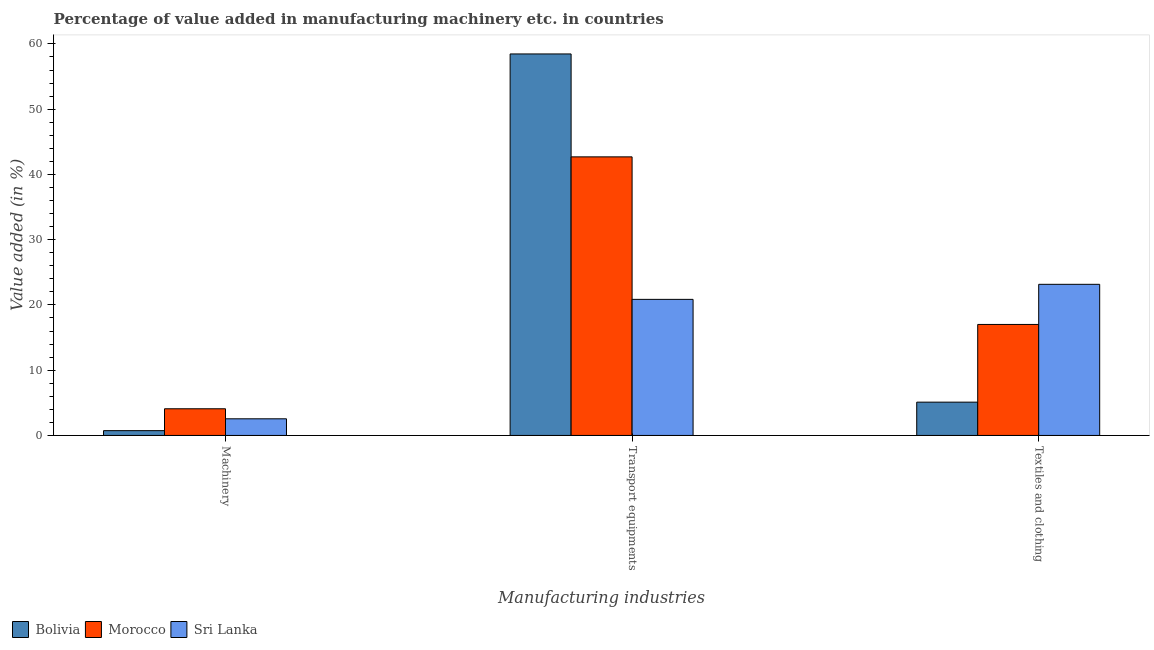How many different coloured bars are there?
Provide a short and direct response. 3. Are the number of bars per tick equal to the number of legend labels?
Your response must be concise. Yes. What is the label of the 2nd group of bars from the left?
Provide a short and direct response. Transport equipments. What is the value added in manufacturing machinery in Morocco?
Give a very brief answer. 4.09. Across all countries, what is the maximum value added in manufacturing transport equipments?
Provide a succinct answer. 58.46. Across all countries, what is the minimum value added in manufacturing transport equipments?
Your response must be concise. 20.85. In which country was the value added in manufacturing textile and clothing maximum?
Ensure brevity in your answer.  Sri Lanka. In which country was the value added in manufacturing textile and clothing minimum?
Your answer should be very brief. Bolivia. What is the total value added in manufacturing textile and clothing in the graph?
Offer a terse response. 45.27. What is the difference between the value added in manufacturing textile and clothing in Morocco and that in Sri Lanka?
Offer a very short reply. -6.15. What is the difference between the value added in manufacturing transport equipments in Bolivia and the value added in manufacturing textile and clothing in Morocco?
Ensure brevity in your answer.  41.45. What is the average value added in manufacturing textile and clothing per country?
Provide a short and direct response. 15.09. What is the difference between the value added in manufacturing machinery and value added in manufacturing textile and clothing in Bolivia?
Make the answer very short. -4.37. What is the ratio of the value added in manufacturing textile and clothing in Bolivia to that in Morocco?
Your answer should be compact. 0.3. Is the value added in manufacturing textile and clothing in Sri Lanka less than that in Bolivia?
Offer a very short reply. No. Is the difference between the value added in manufacturing textile and clothing in Bolivia and Sri Lanka greater than the difference between the value added in manufacturing transport equipments in Bolivia and Sri Lanka?
Provide a succinct answer. No. What is the difference between the highest and the second highest value added in manufacturing transport equipments?
Keep it short and to the point. 15.77. What is the difference between the highest and the lowest value added in manufacturing machinery?
Provide a succinct answer. 3.35. In how many countries, is the value added in manufacturing transport equipments greater than the average value added in manufacturing transport equipments taken over all countries?
Ensure brevity in your answer.  2. What does the 1st bar from the left in Textiles and clothing represents?
Offer a terse response. Bolivia. What does the 1st bar from the right in Transport equipments represents?
Make the answer very short. Sri Lanka. Is it the case that in every country, the sum of the value added in manufacturing machinery and value added in manufacturing transport equipments is greater than the value added in manufacturing textile and clothing?
Offer a terse response. Yes. Are all the bars in the graph horizontal?
Give a very brief answer. No. What is the difference between two consecutive major ticks on the Y-axis?
Give a very brief answer. 10. Are the values on the major ticks of Y-axis written in scientific E-notation?
Your response must be concise. No. Does the graph contain any zero values?
Ensure brevity in your answer.  No. Does the graph contain grids?
Your response must be concise. No. Where does the legend appear in the graph?
Give a very brief answer. Bottom left. How are the legend labels stacked?
Ensure brevity in your answer.  Horizontal. What is the title of the graph?
Provide a short and direct response. Percentage of value added in manufacturing machinery etc. in countries. What is the label or title of the X-axis?
Make the answer very short. Manufacturing industries. What is the label or title of the Y-axis?
Your response must be concise. Value added (in %). What is the Value added (in %) in Bolivia in Machinery?
Offer a very short reply. 0.73. What is the Value added (in %) in Morocco in Machinery?
Give a very brief answer. 4.09. What is the Value added (in %) of Sri Lanka in Machinery?
Your answer should be very brief. 2.55. What is the Value added (in %) of Bolivia in Transport equipments?
Your answer should be very brief. 58.46. What is the Value added (in %) in Morocco in Transport equipments?
Keep it short and to the point. 42.69. What is the Value added (in %) in Sri Lanka in Transport equipments?
Make the answer very short. 20.85. What is the Value added (in %) of Bolivia in Textiles and clothing?
Make the answer very short. 5.1. What is the Value added (in %) of Morocco in Textiles and clothing?
Make the answer very short. 17.01. What is the Value added (in %) of Sri Lanka in Textiles and clothing?
Provide a succinct answer. 23.16. Across all Manufacturing industries, what is the maximum Value added (in %) of Bolivia?
Offer a very short reply. 58.46. Across all Manufacturing industries, what is the maximum Value added (in %) in Morocco?
Your response must be concise. 42.69. Across all Manufacturing industries, what is the maximum Value added (in %) in Sri Lanka?
Your answer should be compact. 23.16. Across all Manufacturing industries, what is the minimum Value added (in %) in Bolivia?
Offer a terse response. 0.73. Across all Manufacturing industries, what is the minimum Value added (in %) of Morocco?
Offer a terse response. 4.09. Across all Manufacturing industries, what is the minimum Value added (in %) of Sri Lanka?
Provide a succinct answer. 2.55. What is the total Value added (in %) of Bolivia in the graph?
Your answer should be compact. 64.3. What is the total Value added (in %) of Morocco in the graph?
Provide a short and direct response. 63.79. What is the total Value added (in %) of Sri Lanka in the graph?
Your answer should be very brief. 46.56. What is the difference between the Value added (in %) in Bolivia in Machinery and that in Transport equipments?
Your answer should be compact. -57.73. What is the difference between the Value added (in %) of Morocco in Machinery and that in Transport equipments?
Ensure brevity in your answer.  -38.6. What is the difference between the Value added (in %) in Sri Lanka in Machinery and that in Transport equipments?
Offer a very short reply. -18.3. What is the difference between the Value added (in %) in Bolivia in Machinery and that in Textiles and clothing?
Offer a terse response. -4.37. What is the difference between the Value added (in %) in Morocco in Machinery and that in Textiles and clothing?
Your answer should be compact. -12.92. What is the difference between the Value added (in %) in Sri Lanka in Machinery and that in Textiles and clothing?
Give a very brief answer. -20.61. What is the difference between the Value added (in %) of Bolivia in Transport equipments and that in Textiles and clothing?
Offer a terse response. 53.36. What is the difference between the Value added (in %) of Morocco in Transport equipments and that in Textiles and clothing?
Give a very brief answer. 25.68. What is the difference between the Value added (in %) in Sri Lanka in Transport equipments and that in Textiles and clothing?
Make the answer very short. -2.31. What is the difference between the Value added (in %) of Bolivia in Machinery and the Value added (in %) of Morocco in Transport equipments?
Give a very brief answer. -41.96. What is the difference between the Value added (in %) in Bolivia in Machinery and the Value added (in %) in Sri Lanka in Transport equipments?
Keep it short and to the point. -20.12. What is the difference between the Value added (in %) of Morocco in Machinery and the Value added (in %) of Sri Lanka in Transport equipments?
Keep it short and to the point. -16.77. What is the difference between the Value added (in %) in Bolivia in Machinery and the Value added (in %) in Morocco in Textiles and clothing?
Keep it short and to the point. -16.28. What is the difference between the Value added (in %) in Bolivia in Machinery and the Value added (in %) in Sri Lanka in Textiles and clothing?
Make the answer very short. -22.43. What is the difference between the Value added (in %) of Morocco in Machinery and the Value added (in %) of Sri Lanka in Textiles and clothing?
Offer a terse response. -19.07. What is the difference between the Value added (in %) in Bolivia in Transport equipments and the Value added (in %) in Morocco in Textiles and clothing?
Offer a very short reply. 41.45. What is the difference between the Value added (in %) of Bolivia in Transport equipments and the Value added (in %) of Sri Lanka in Textiles and clothing?
Offer a terse response. 35.3. What is the difference between the Value added (in %) in Morocco in Transport equipments and the Value added (in %) in Sri Lanka in Textiles and clothing?
Your response must be concise. 19.53. What is the average Value added (in %) of Bolivia per Manufacturing industries?
Provide a short and direct response. 21.43. What is the average Value added (in %) of Morocco per Manufacturing industries?
Your response must be concise. 21.26. What is the average Value added (in %) in Sri Lanka per Manufacturing industries?
Ensure brevity in your answer.  15.52. What is the difference between the Value added (in %) of Bolivia and Value added (in %) of Morocco in Machinery?
Your answer should be compact. -3.35. What is the difference between the Value added (in %) of Bolivia and Value added (in %) of Sri Lanka in Machinery?
Give a very brief answer. -1.81. What is the difference between the Value added (in %) in Morocco and Value added (in %) in Sri Lanka in Machinery?
Make the answer very short. 1.54. What is the difference between the Value added (in %) in Bolivia and Value added (in %) in Morocco in Transport equipments?
Keep it short and to the point. 15.77. What is the difference between the Value added (in %) of Bolivia and Value added (in %) of Sri Lanka in Transport equipments?
Ensure brevity in your answer.  37.61. What is the difference between the Value added (in %) of Morocco and Value added (in %) of Sri Lanka in Transport equipments?
Provide a short and direct response. 21.84. What is the difference between the Value added (in %) of Bolivia and Value added (in %) of Morocco in Textiles and clothing?
Give a very brief answer. -11.91. What is the difference between the Value added (in %) of Bolivia and Value added (in %) of Sri Lanka in Textiles and clothing?
Give a very brief answer. -18.06. What is the difference between the Value added (in %) of Morocco and Value added (in %) of Sri Lanka in Textiles and clothing?
Provide a short and direct response. -6.15. What is the ratio of the Value added (in %) in Bolivia in Machinery to that in Transport equipments?
Your answer should be compact. 0.01. What is the ratio of the Value added (in %) in Morocco in Machinery to that in Transport equipments?
Provide a short and direct response. 0.1. What is the ratio of the Value added (in %) of Sri Lanka in Machinery to that in Transport equipments?
Your response must be concise. 0.12. What is the ratio of the Value added (in %) in Bolivia in Machinery to that in Textiles and clothing?
Keep it short and to the point. 0.14. What is the ratio of the Value added (in %) in Morocco in Machinery to that in Textiles and clothing?
Your answer should be compact. 0.24. What is the ratio of the Value added (in %) of Sri Lanka in Machinery to that in Textiles and clothing?
Make the answer very short. 0.11. What is the ratio of the Value added (in %) of Bolivia in Transport equipments to that in Textiles and clothing?
Give a very brief answer. 11.46. What is the ratio of the Value added (in %) of Morocco in Transport equipments to that in Textiles and clothing?
Ensure brevity in your answer.  2.51. What is the ratio of the Value added (in %) of Sri Lanka in Transport equipments to that in Textiles and clothing?
Provide a succinct answer. 0.9. What is the difference between the highest and the second highest Value added (in %) of Bolivia?
Your response must be concise. 53.36. What is the difference between the highest and the second highest Value added (in %) of Morocco?
Keep it short and to the point. 25.68. What is the difference between the highest and the second highest Value added (in %) of Sri Lanka?
Your answer should be compact. 2.31. What is the difference between the highest and the lowest Value added (in %) in Bolivia?
Provide a short and direct response. 57.73. What is the difference between the highest and the lowest Value added (in %) of Morocco?
Your answer should be compact. 38.6. What is the difference between the highest and the lowest Value added (in %) of Sri Lanka?
Your answer should be compact. 20.61. 